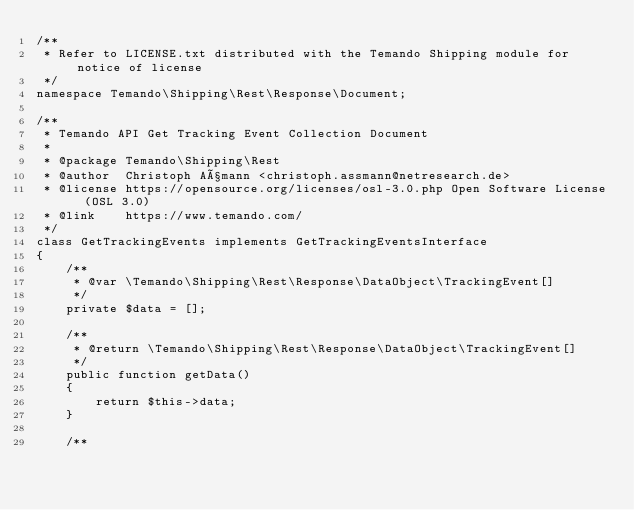Convert code to text. <code><loc_0><loc_0><loc_500><loc_500><_PHP_>/**
 * Refer to LICENSE.txt distributed with the Temando Shipping module for notice of license
 */
namespace Temando\Shipping\Rest\Response\Document;

/**
 * Temando API Get Tracking Event Collection Document
 *
 * @package Temando\Shipping\Rest
 * @author  Christoph Aßmann <christoph.assmann@netresearch.de>
 * @license https://opensource.org/licenses/osl-3.0.php Open Software License (OSL 3.0)
 * @link    https://www.temando.com/
 */
class GetTrackingEvents implements GetTrackingEventsInterface
{
    /**
     * @var \Temando\Shipping\Rest\Response\DataObject\TrackingEvent[]
     */
    private $data = [];

    /**
     * @return \Temando\Shipping\Rest\Response\DataObject\TrackingEvent[]
     */
    public function getData()
    {
        return $this->data;
    }

    /**</code> 